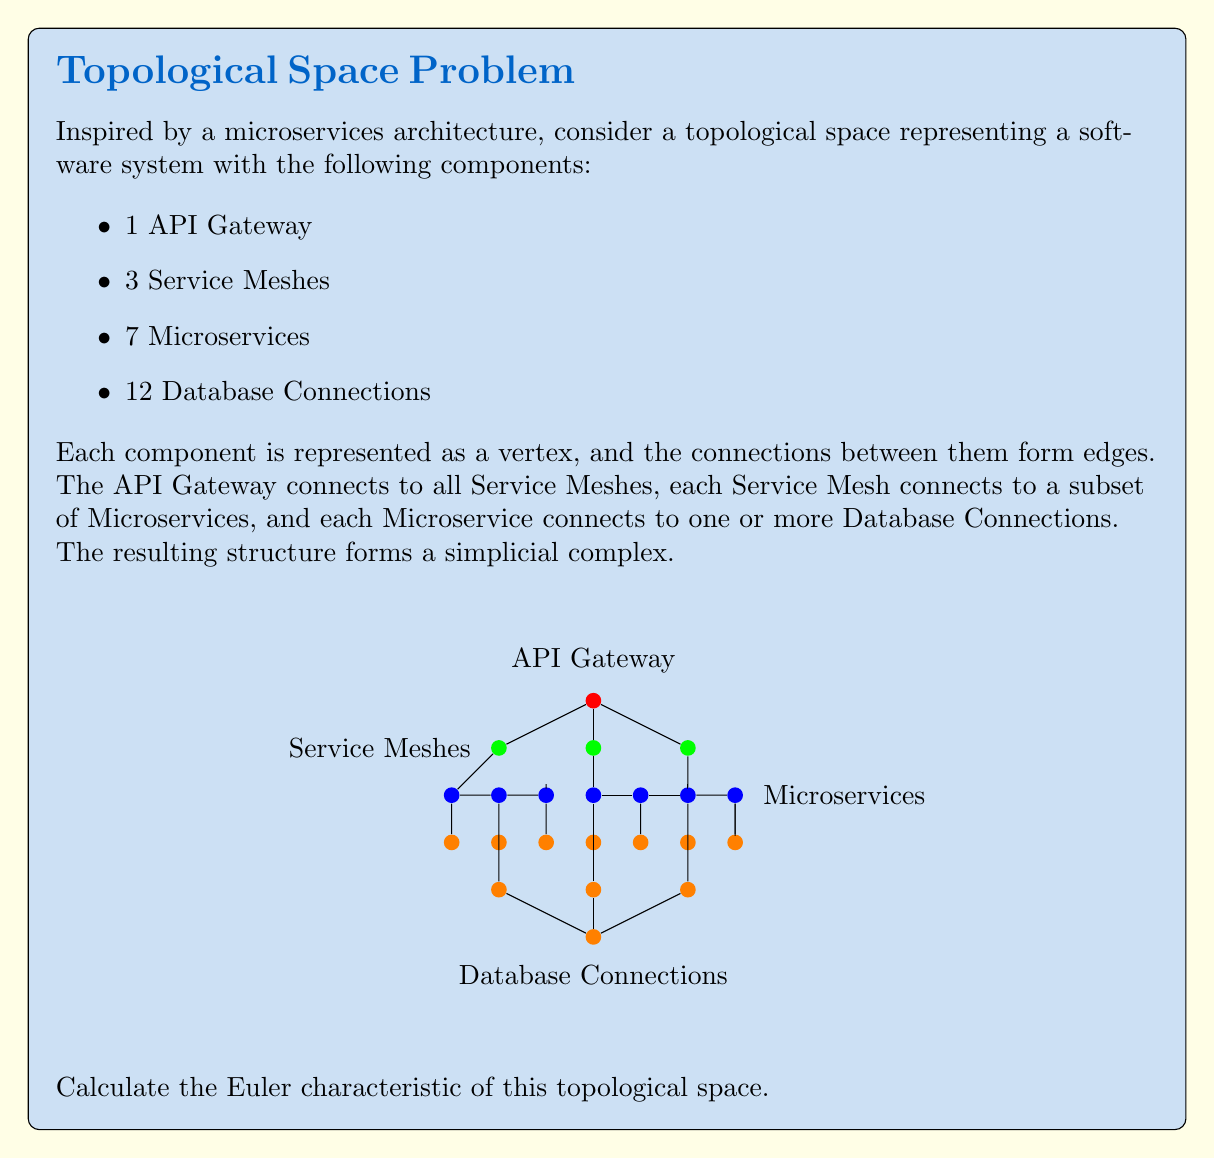Could you help me with this problem? To calculate the Euler characteristic of this topological space, we need to determine the number of vertices, edges, and faces (2-simplices) in the simplicial complex. Let's break it down step by step:

1. Count the vertices (0-simplices):
   - 1 API Gateway
   - 3 Service Meshes
   - 7 Microservices
   - 12 Database Connections
   Total vertices: $v = 1 + 3 + 7 + 12 = 23$

2. Count the edges (1-simplices):
   - API Gateway to Service Meshes: 3
   - Service Meshes to Microservices: 7 (assuming each Microservice connects to one Service Mesh)
   - Microservices to Database Connections: 12 (assuming each Database Connection connects to one Microservice)
   Total edges: $e = 3 + 7 + 12 = 22$

3. Count the faces (2-simplices):
   - Triangles formed by API Gateway, Service Meshes, and Microservices: 3
   Total faces: $f = 3$

Now, we can apply the formula for the Euler characteristic:

$$\chi = v - e + f$$

Where:
$\chi$ is the Euler characteristic
$v$ is the number of vertices
$e$ is the number of edges
$f$ is the number of faces

Substituting our values:

$$\chi = 23 - 22 + 3 = 4$$
Answer: $\chi = 4$ 